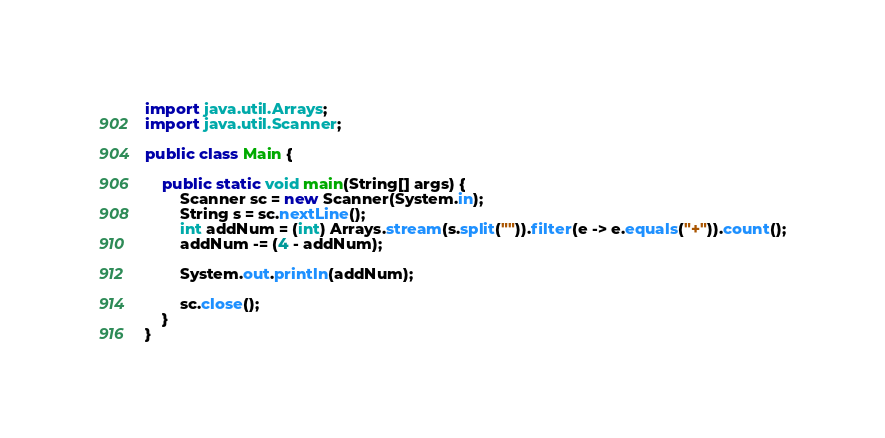Convert code to text. <code><loc_0><loc_0><loc_500><loc_500><_Java_>import java.util.Arrays;
import java.util.Scanner;

public class Main {

	public static void main(String[] args) {
		Scanner sc = new Scanner(System.in);
		String s = sc.nextLine();
		int addNum = (int) Arrays.stream(s.split("")).filter(e -> e.equals("+")).count();
		addNum -= (4 - addNum);

		System.out.println(addNum);

		sc.close();
	}
}</code> 